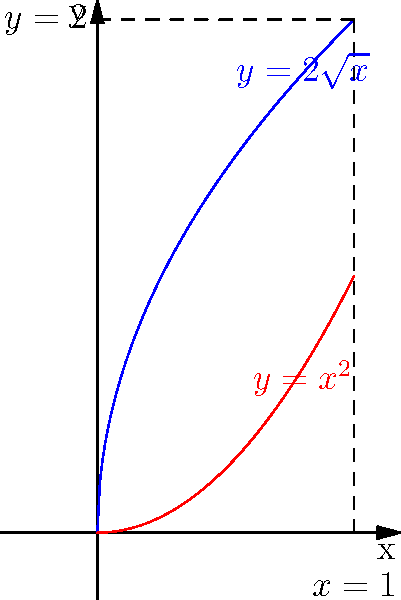As a team lead collaborating with a senior Portuguese researcher, you're tasked with solving a problem that requires finding the volume of a solid formed by rotating a region bounded by two curves around an axis. The region is bounded by the curves $y = 2\sqrt{x}$ and $y = x^2$ from $x = 0$ to $x = 1$, and is rotated around the y-axis. Calculate the volume of the resulting solid. To solve this problem, we'll use the shell method for calculating the volume of a solid of revolution. Let's break it down step-by-step:

1) The shell method formula for rotating around the y-axis is:
   $$V = 2\pi \int_a^b x[f(x) - g(x)] dx$$
   where $f(x)$ is the outer function and $g(x)$ is the inner function.

2) In our case:
   $f(x) = 2\sqrt{x}$ (outer curve)
   $g(x) = x^2$ (inner curve)
   $a = 0$ and $b = 1$ (limits of integration)

3) Substituting into the formula:
   $$V = 2\pi \int_0^1 x[2\sqrt{x} - x^2] dx$$

4) Simplify the integrand:
   $$V = 2\pi \int_0^1 (2x\sqrt{x} - x^3) dx$$

5) Integrate:
   $$V = 2\pi [\frac{4}{5}x^{5/2} - \frac{1}{4}x^4]_0^1$$

6) Evaluate the integral:
   $$V = 2\pi [(\frac{4}{5} - \frac{1}{4}) - (0 - 0)]$$
   $$V = 2\pi [\frac{16}{20} - \frac{5}{20}]$$
   $$V = 2\pi [\frac{11}{20}]$$

7) Simplify:
   $$V = \frac{11\pi}{10}$$

This approach demonstrates problem-solving skills by breaking down a complex problem into manageable steps, which is valuable in a collaborative software engineering environment.
Answer: $\frac{11\pi}{10}$ cubic units 